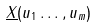<formula> <loc_0><loc_0><loc_500><loc_500>\underline { X } ( u _ { 1 } \dots , u _ { m } )</formula> 